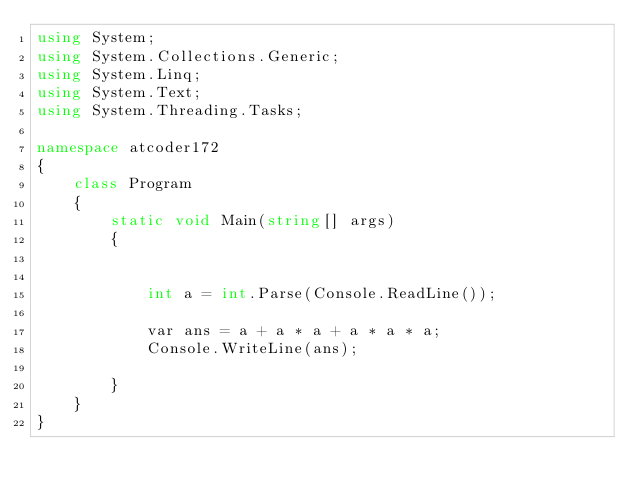Convert code to text. <code><loc_0><loc_0><loc_500><loc_500><_C#_>using System;
using System.Collections.Generic;
using System.Linq;
using System.Text;
using System.Threading.Tasks;

namespace atcoder172
{
    class Program
    {
        static void Main(string[] args)
        {


            int a = int.Parse(Console.ReadLine());

            var ans = a + a * a + a * a * a;
            Console.WriteLine(ans);

        }
    }
}
</code> 